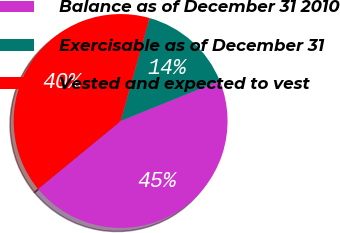<chart> <loc_0><loc_0><loc_500><loc_500><pie_chart><fcel>Balance as of December 31 2010<fcel>Exercisable as of December 31<fcel>Vested and expected to vest<nl><fcel>45.2%<fcel>14.5%<fcel>40.31%<nl></chart> 